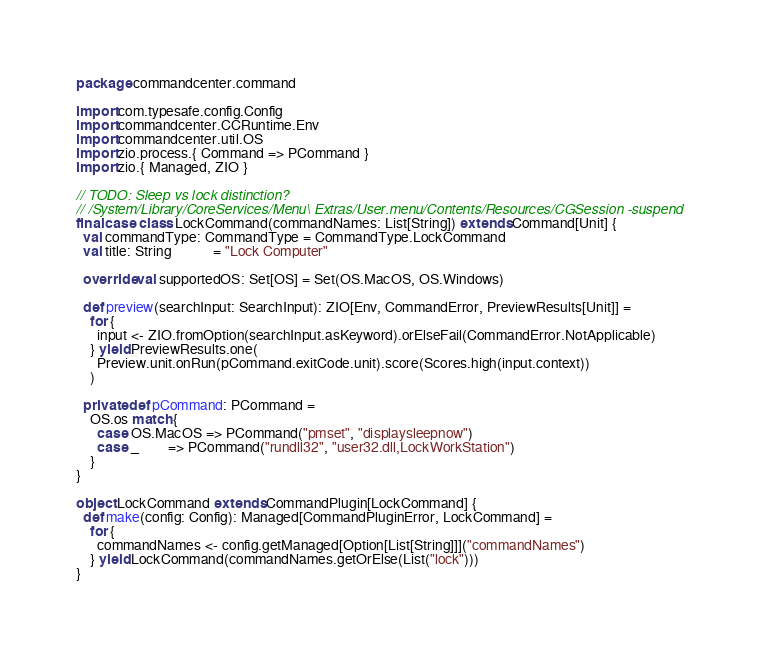<code> <loc_0><loc_0><loc_500><loc_500><_Scala_>package commandcenter.command

import com.typesafe.config.Config
import commandcenter.CCRuntime.Env
import commandcenter.util.OS
import zio.process.{ Command => PCommand }
import zio.{ Managed, ZIO }

// TODO: Sleep vs lock distinction?
// /System/Library/CoreServices/Menu\ Extras/User.menu/Contents/Resources/CGSession -suspend
final case class LockCommand(commandNames: List[String]) extends Command[Unit] {
  val commandType: CommandType = CommandType.LockCommand
  val title: String            = "Lock Computer"

  override val supportedOS: Set[OS] = Set(OS.MacOS, OS.Windows)

  def preview(searchInput: SearchInput): ZIO[Env, CommandError, PreviewResults[Unit]] =
    for {
      input <- ZIO.fromOption(searchInput.asKeyword).orElseFail(CommandError.NotApplicable)
    } yield PreviewResults.one(
      Preview.unit.onRun(pCommand.exitCode.unit).score(Scores.high(input.context))
    )

  private def pCommand: PCommand =
    OS.os match {
      case OS.MacOS => PCommand("pmset", "displaysleepnow")
      case _        => PCommand("rundll32", "user32.dll,LockWorkStation")
    }
}

object LockCommand extends CommandPlugin[LockCommand] {
  def make(config: Config): Managed[CommandPluginError, LockCommand] =
    for {
      commandNames <- config.getManaged[Option[List[String]]]("commandNames")
    } yield LockCommand(commandNames.getOrElse(List("lock")))
}
</code> 